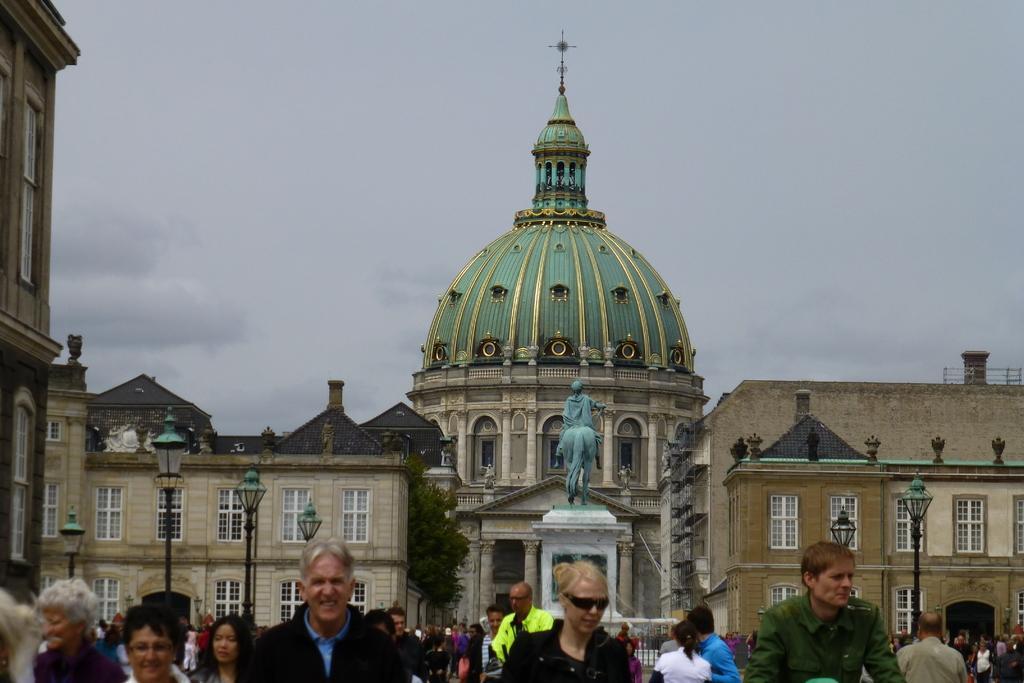Describe this image in one or two sentences. In this image we can see there are people walking on the road. At the back there are buildings and sculpture attached to the pillar. And there are light poles and the sky. 